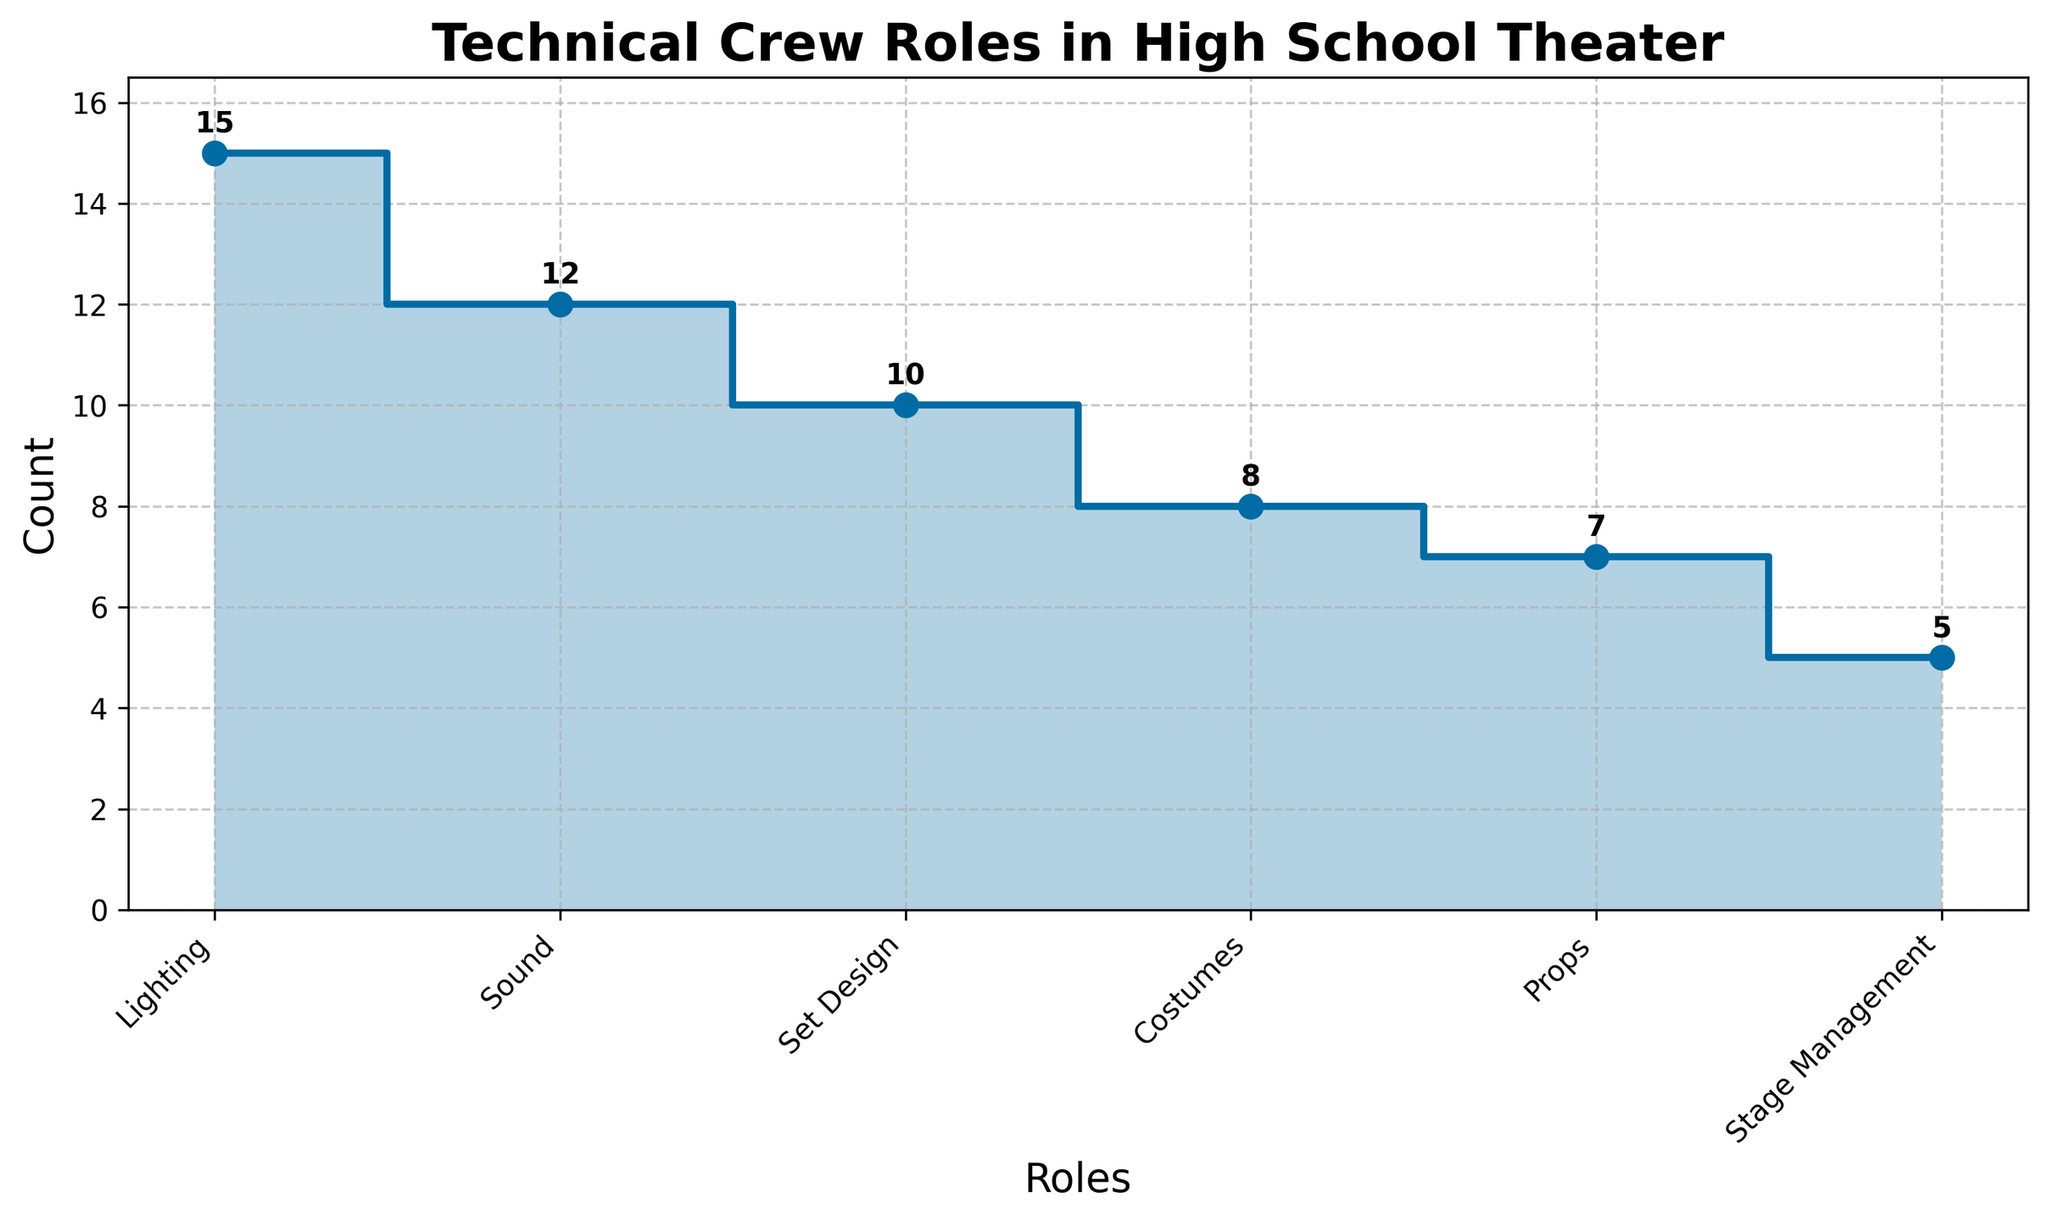What's the title of the chart? The title is prominently displayed at the top of the chart. It reads "Technical Crew Roles in High School Theater".
Answer: Technical Crew Roles in High School Theater How many technical crew roles are represented in the figure? Count the number of distinct roles on the x-axis. There are six roles listed.
Answer: Six Which technical crew role has the highest count? Look at the stair plot and identify the role with the highest point on the y-axis. The role "Lighting" has the highest count at 15.
Answer: Lighting What is the count for the Sound role? Locate the point on the stair plot corresponding to "Sound" on the x-axis and read the value on the y-axis. The count is 12.
Answer: 12 How much higher is the count for Lighting compared to Costumes? Subtract the count for Costumes (8) from the count for Lighting (15). 15 - 8 = 7.
Answer: 7 What is the average count for all the technical crew roles represented? Sum all the counts (15 + 12 + 10 + 8 + 7 + 5) and divide by the number of roles (6). The average is (15 + 12 + 10 + 8 + 7 + 5) / 6 = 57 / 6 ≈ 9.5.
Answer: 9.5 Which role has the smallest count? Identify the lowest point on the y-axis of the stair plot. The role "Stage Management" has the smallest count at 5.
Answer: Stage Management What is the total count for Props and Stage Management? Add the counts for Props (7) and Stage Management (5). 7 + 5 = 12.
Answer: 12 Which roles have a count greater than 10? Identify the roles on the stair plot that have points above 10 on the y-axis. "Lighting" and "Sound" both have counts greater than 10.
Answer: Lighting, Sound By how much do Set Design counts exceed Props counts? Subtract the count for Props (7) from the count for Set Design (10). 10 - 7 = 3.
Answer: 3 